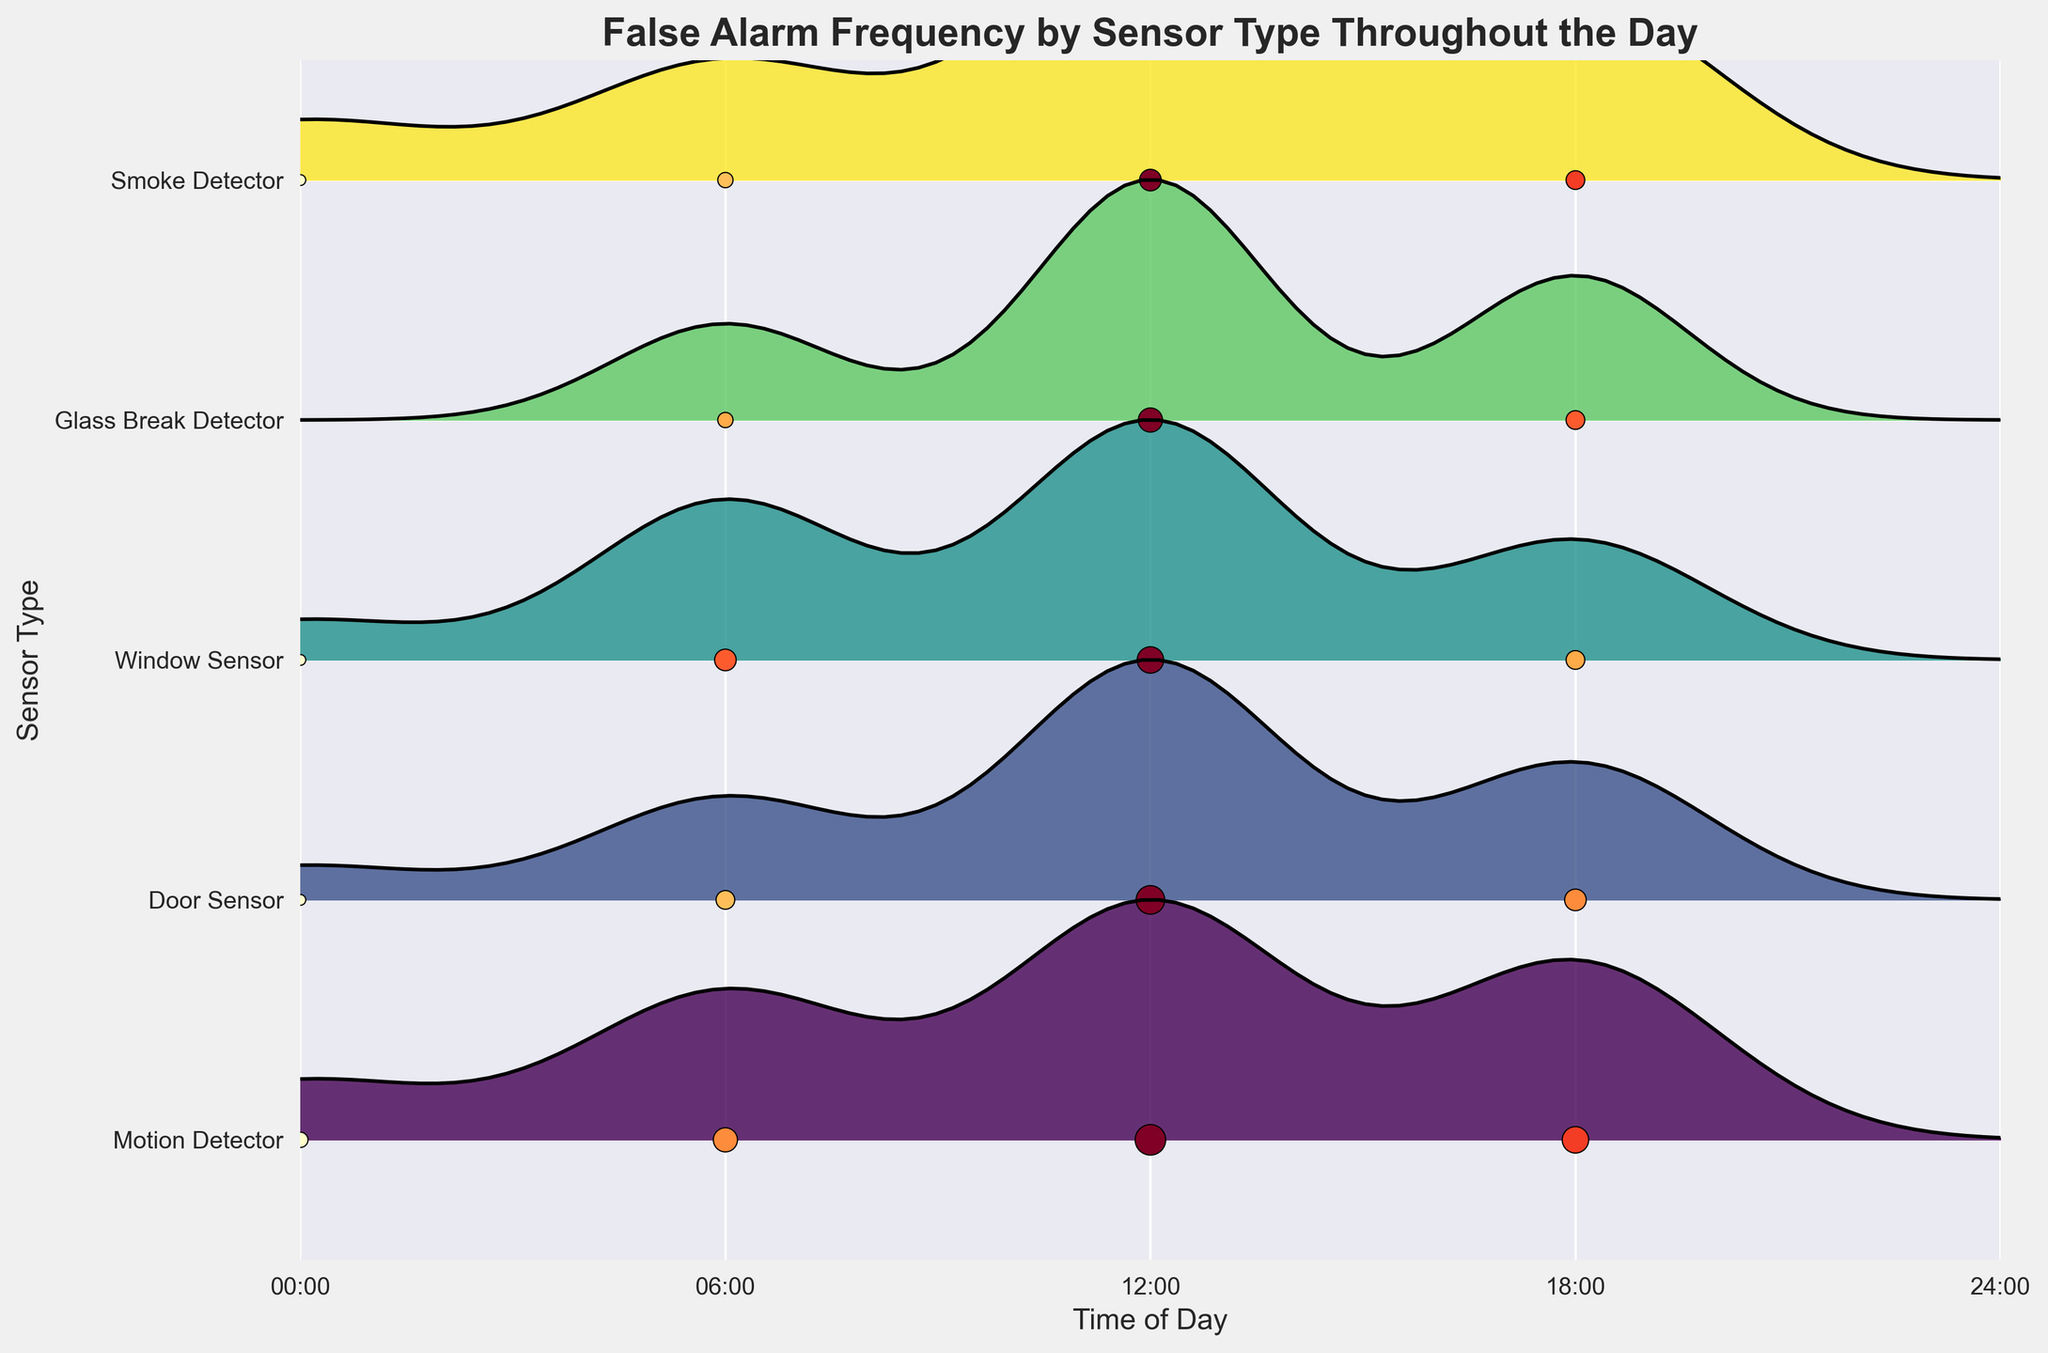What's the title of the plot? The title of the plot is displayed at the top center in bold font. It provides a summary of what the plot represents.
Answer: False Alarm Frequency by Sensor Type Throughout the Day What are the labels on the x-axis? The labels on the x-axis are shown at the bottom of the plot. They indicate the time of day at 6-hour intervals starting from 00:00, 06:00, 12:00, 18:00, and ending at 24:00.
Answer: 00:00, 06:00, 12:00, 18:00, 24:00 Which sensor type has the highest frequency of false alarms at noon (12:00)? By looking at the scatter points and the ridgelines at the 12:00 (noon) mark, we can identify the sensor type with the highest frequency. The Motion Detector has the highest peak at this time.
Answer: Motion Detector What is the typical pattern of false alarm frequencies for the Door Sensor throughout the day? Examine the ridgeline and scatter points corresponding to the Door Sensor row. The pattern shows an increase in frequency from 1 at midnight, peaking at 7 at noon, and slightly lower values at other times.
Answer: Increases from midnight, peaks at noon, and reduces in the evening Which sensor type has the most uniform distribution of false alarms over the day? By assessing the ridgeline shapes and scatter points, the sensor with the most uniform distribution has no significant peaks. The Smoke Detector has relatively even false alarm frequencies across different times.
Answer: Smoke Detector How do the false alarm frequencies of the Window Sensor compare between 6:00 and 18:00? Compare the heights and scatter points at 6:00 and 18:00 for the Window Sensor. The frequencies are 4 at 6:00 and 3 at 18:00, indicating a slightly higher frequency in the morning.
Answer: Higher at 6:00 than at 18:00 Which sensor type shows the greatest increase in false alarms from midnight to noon? Analyze the differences in false alarm frequencies between 00:00 and 12:00 for each sensor type. The Door Sensor shows an increase from 1 to 7, the largest rise.
Answer: Door Sensor What's the dominant trend for the Motion Detector's false alarms over the 24-hour period? Evaluate the scatter points and the ridgeline of the Motion Detector. False alarms are lowest at midnight, rise to a peak at noon, then decrease slightly again.
Answer: Lowest at midnight, peaks at noon Is there any sensor that does not trigger any false alarms at a particular time of day? Look at the scatter points for each sensor type. The Glass Break Detector does not trigger any false alarms at midnight (00:00).
Answer: Glass Break Detector at midnight 